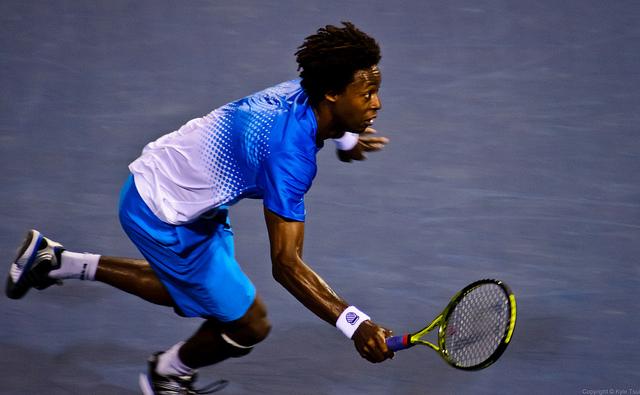What color is the racket?
Quick response, please. Black. Is the man wearing sneakers?
Answer briefly. Yes. Is the man playing soccer?
Quick response, please. No. What color is the man shorts?
Give a very brief answer. Blue. What brand is the racket?
Keep it brief. Wilson. 